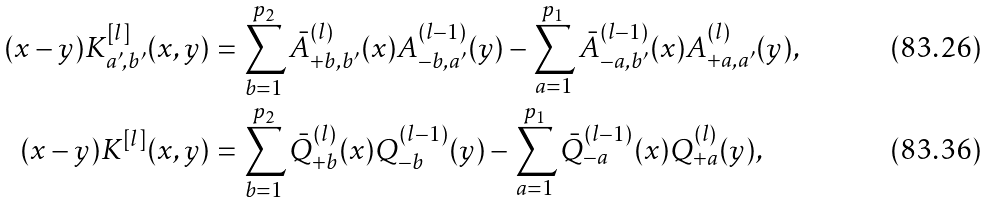<formula> <loc_0><loc_0><loc_500><loc_500>( x - y ) K _ { a ^ { \prime } , b ^ { \prime } } ^ { [ l ] } ( x , y ) & = \sum _ { b = 1 } ^ { p _ { 2 } } \bar { A } _ { + b , b ^ { \prime } } ^ { ( l ) } ( x ) A _ { - b , a ^ { \prime } } ^ { ( l - 1 ) } ( y ) - \sum _ { a = 1 } ^ { p _ { 1 } } \bar { A } ^ { ( l - 1 ) } _ { - a , b ^ { \prime } } ( x ) A ^ { ( l ) } _ { + a , a ^ { \prime } } ( y ) , \\ ( x - y ) K ^ { [ l ] } ( x , y ) & = \sum _ { b = 1 } ^ { p _ { 2 } } \bar { Q } _ { + b } ^ { ( l ) } ( x ) Q _ { - b } ^ { ( l - 1 ) } ( y ) - \sum _ { a = 1 } ^ { p _ { 1 } } \bar { Q } ^ { ( l - 1 ) } _ { - a } ( x ) Q ^ { ( l ) } _ { + a } ( y ) ,</formula> 